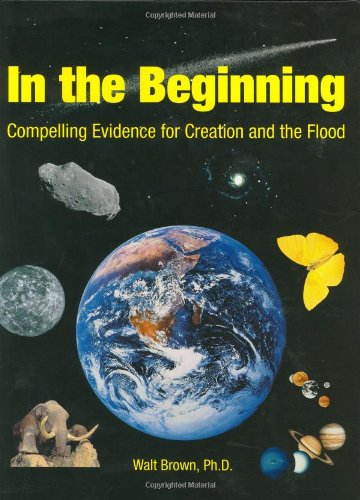Are there any notable illustrations or diagrams in this book that help explain its theories? Yes, the book features numerous illustrations and diagrams that attempt to visualize and support the complex scientific and biblical arguments made about the origin of the Earth and life on it. 